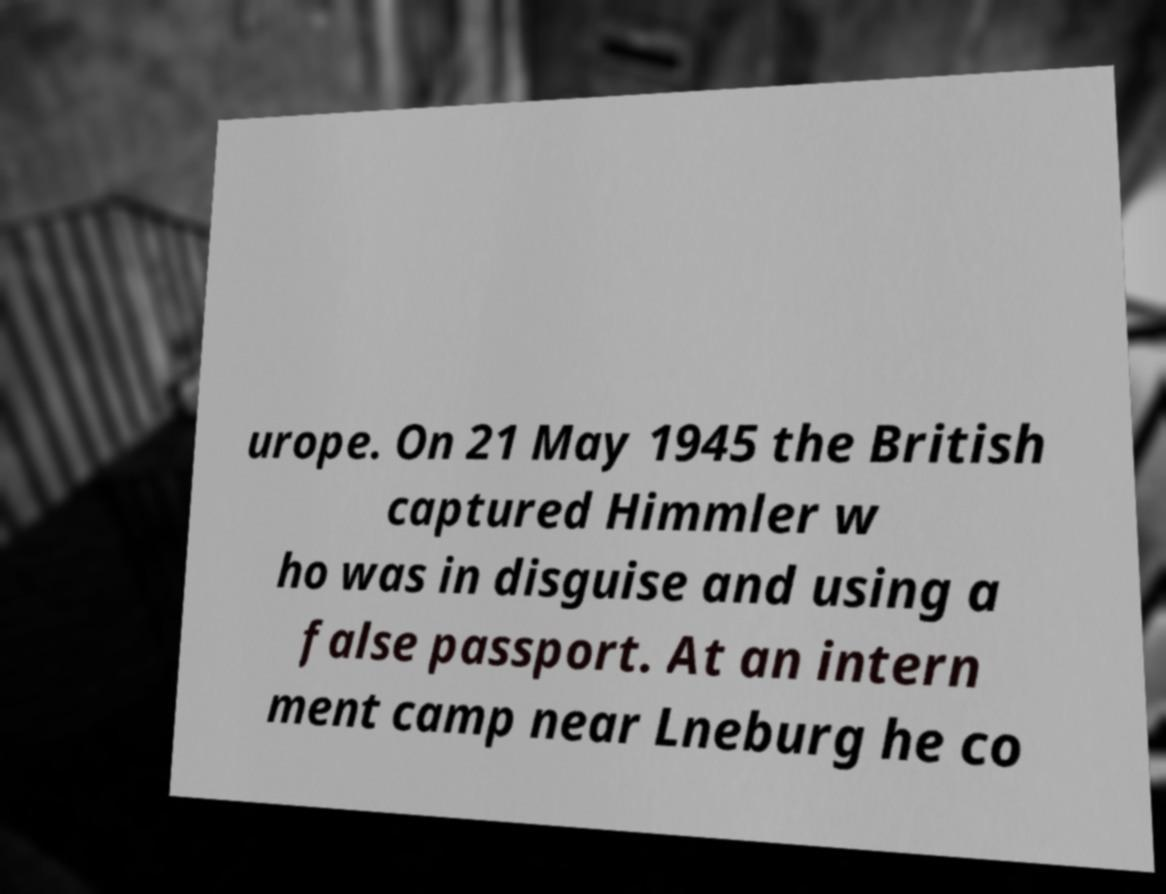Could you extract and type out the text from this image? urope. On 21 May 1945 the British captured Himmler w ho was in disguise and using a false passport. At an intern ment camp near Lneburg he co 